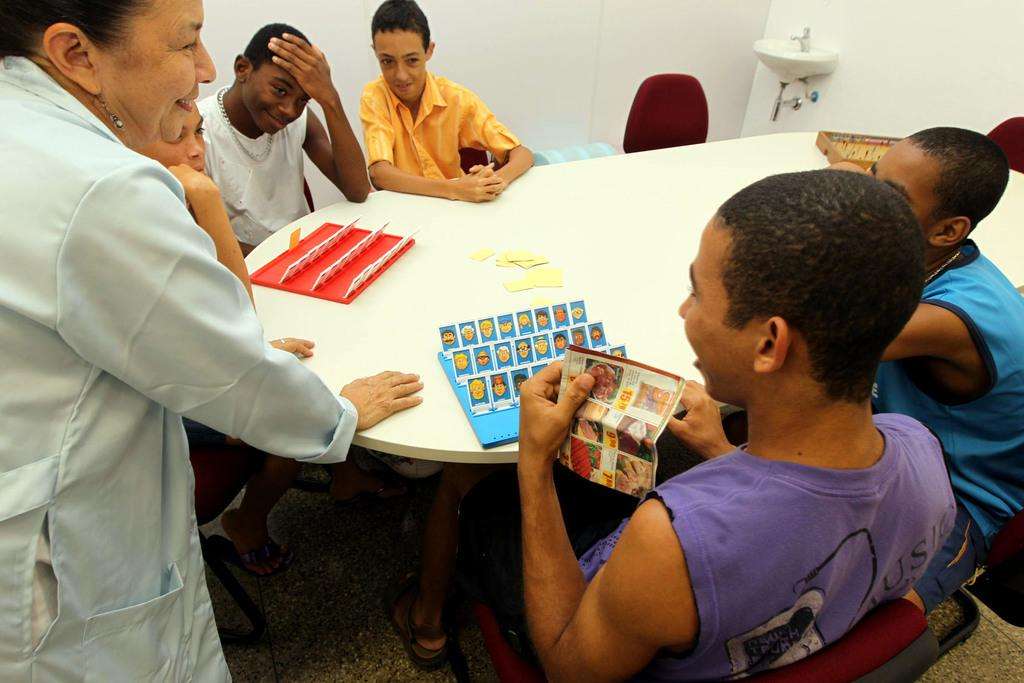What are the people in the image doing? There are men sitting at a table, and a woman is standing on the right side. What type of furniture is present in the image? There are chairs in the image. What can be seen near the men sitting at the table? There is a sink in the image. What is the background of the image made of? There is a wall in the image. How many children are present in the image? There are no children present in the image. What type of bit is being used by the woman standing on the right side? There is no bit present in the image, as it is not a tool or object used by the woman. 